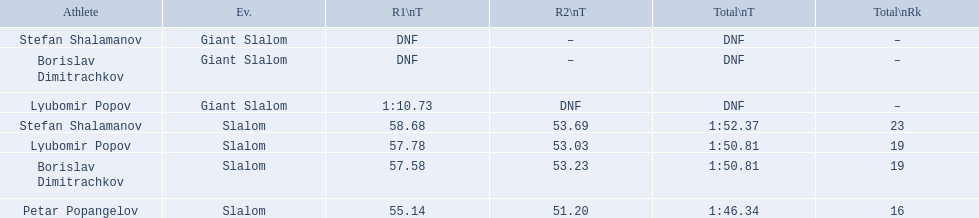What were the event names during bulgaria at the 1988 winter olympics? Stefan Shalamanov, Borislav Dimitrachkov, Lyubomir Popov. And which players participated at giant slalom? Giant Slalom, Giant Slalom, Giant Slalom, Slalom, Slalom, Slalom, Slalom. What were their race 1 times? DNF, DNF, 1:10.73. What was lyubomir popov's personal time? 1:10.73. 